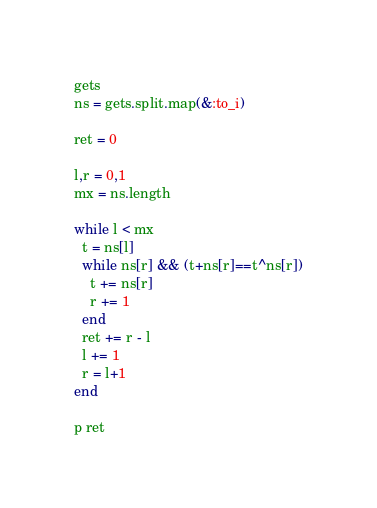<code> <loc_0><loc_0><loc_500><loc_500><_Ruby_>gets
ns = gets.split.map(&:to_i)

ret = 0

l,r = 0,1
mx = ns.length

while l < mx
  t = ns[l]
  while ns[r] && (t+ns[r]==t^ns[r])
    t += ns[r]
    r += 1
  end
  ret += r - l
  l += 1
  r = l+1
end

p ret</code> 